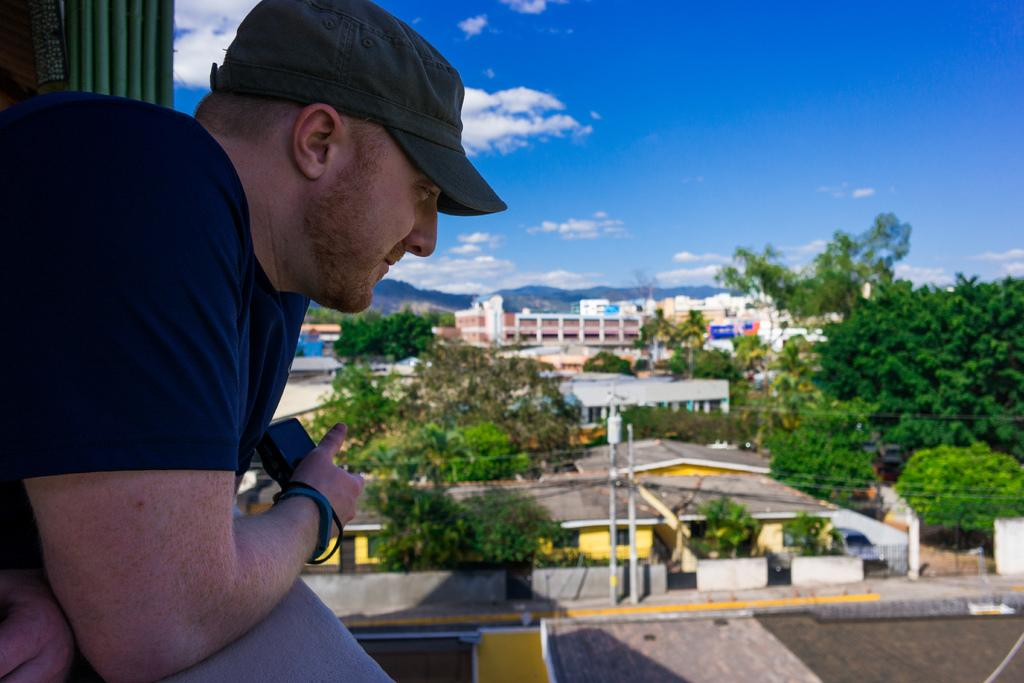What is the person in the image holding? There is a person holding an object in the image. What type of structures can be seen in the image? There are buildings in the image. What other natural elements are present in the image? There are trees in the image. What are the vertical structures in the image used for? There are poles in the image, which are likely used for support or signage. What can be seen above the buildings and trees in the image? The sky is visible in the image, and clouds are present in the sky. Reasoning: Let'g: Let's think step by step in order to produce the conversation. We start by identifying the main subject in the image, which is the person holding an object. Then, we expand the conversation to include other elements in the image, such as buildings, trees, poles, and the sky. Each question is designed to elicit a specific detail about the image that is known from the provided facts. Absurd Question/Answer: What type of card is the person using to cover their face in the image? There is no card or face covering present in the image. 